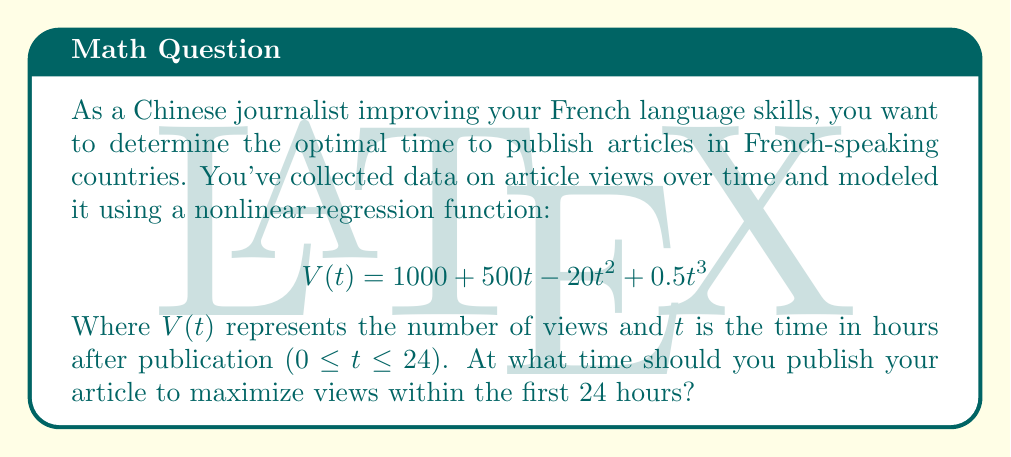Provide a solution to this math problem. To find the optimal time for maximum views, we need to find the maximum of the function $V(t)$ within the given interval [0, 24].

Step 1: Calculate the derivative of $V(t)$:
$$V'(t) = 500 - 40t + 1.5t^2$$

Step 2: Set the derivative equal to zero and solve for t:
$$500 - 40t + 1.5t^2 = 0$$
$$1.5t^2 - 40t + 500 = 0$$

Step 3: Use the quadratic formula to solve this equation:
$$t = \frac{40 \pm \sqrt{40^2 - 4(1.5)(500)}}{2(1.5)}$$
$$t = \frac{40 \pm \sqrt{1600 - 3000}}{3}$$
$$t = \frac{40 \pm \sqrt{-1400}}{3}$$

Since the discriminant is negative, there are no real solutions within our domain.

Step 4: Check the endpoints of the interval [0, 24]:
$$V(0) = 1000$$
$$V(24) = 1000 + 500(24) - 20(24)^2 + 0.5(24)^3 = 109,000$$

Step 5: Since there are no critical points within the interval and $V(24) > V(0)$, the maximum occurs at t = 24.
Answer: 24 hours 